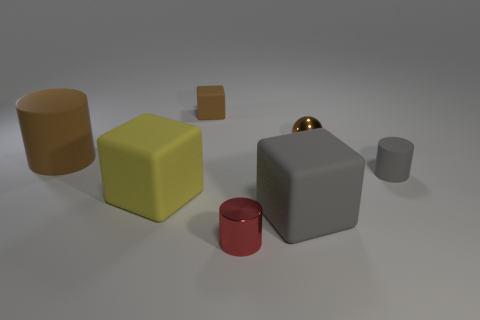Add 2 purple objects. How many objects exist? 9 Subtract all cylinders. How many objects are left? 4 Add 3 red metallic objects. How many red metallic objects exist? 4 Subtract 0 red balls. How many objects are left? 7 Subtract all tiny metallic balls. Subtract all big brown rubber cylinders. How many objects are left? 5 Add 1 large gray rubber cubes. How many large gray rubber cubes are left? 2 